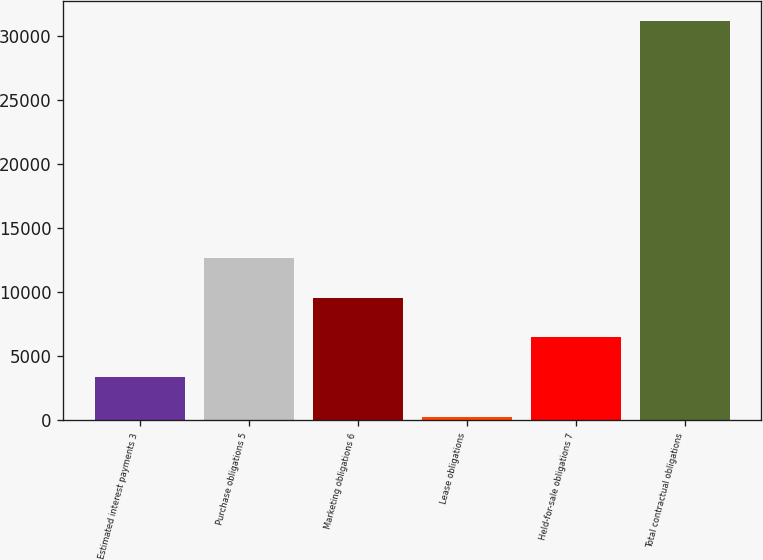<chart> <loc_0><loc_0><loc_500><loc_500><bar_chart><fcel>Estimated interest payments 3<fcel>Purchase obligations 5<fcel>Marketing obligations 6<fcel>Lease obligations<fcel>Held-for-sale obligations 7<fcel>Total contractual obligations<nl><fcel>3363.9<fcel>12636.6<fcel>9545.7<fcel>273<fcel>6454.8<fcel>31182<nl></chart> 